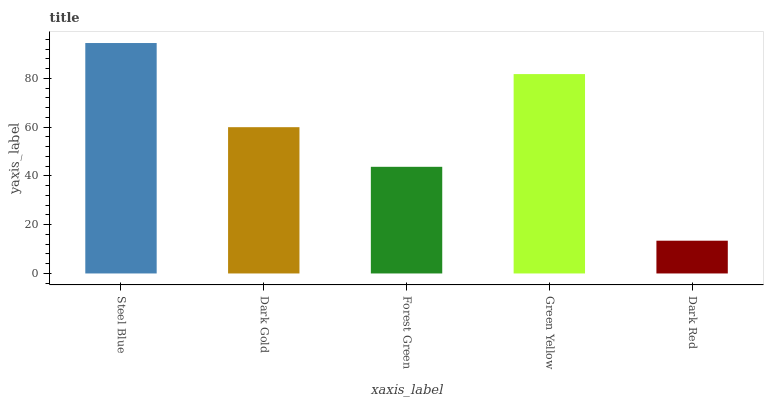Is Dark Red the minimum?
Answer yes or no. Yes. Is Steel Blue the maximum?
Answer yes or no. Yes. Is Dark Gold the minimum?
Answer yes or no. No. Is Dark Gold the maximum?
Answer yes or no. No. Is Steel Blue greater than Dark Gold?
Answer yes or no. Yes. Is Dark Gold less than Steel Blue?
Answer yes or no. Yes. Is Dark Gold greater than Steel Blue?
Answer yes or no. No. Is Steel Blue less than Dark Gold?
Answer yes or no. No. Is Dark Gold the high median?
Answer yes or no. Yes. Is Dark Gold the low median?
Answer yes or no. Yes. Is Steel Blue the high median?
Answer yes or no. No. Is Steel Blue the low median?
Answer yes or no. No. 